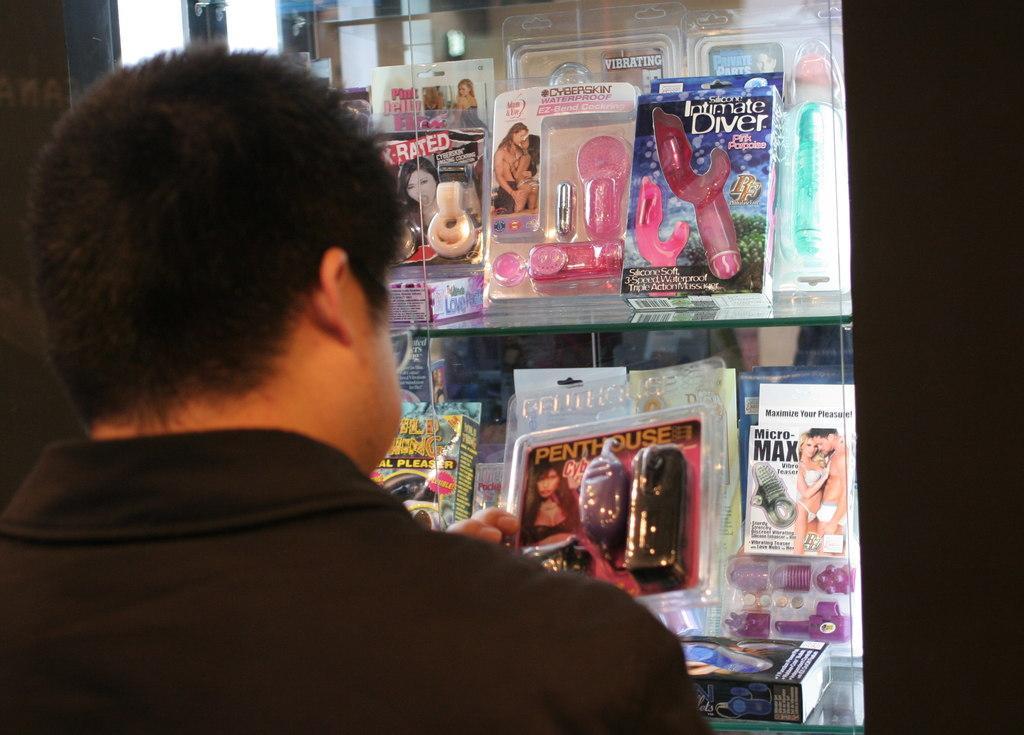Describe this image in one or two sentences. In this image there is a person seeing some packets. There is a black color background. 